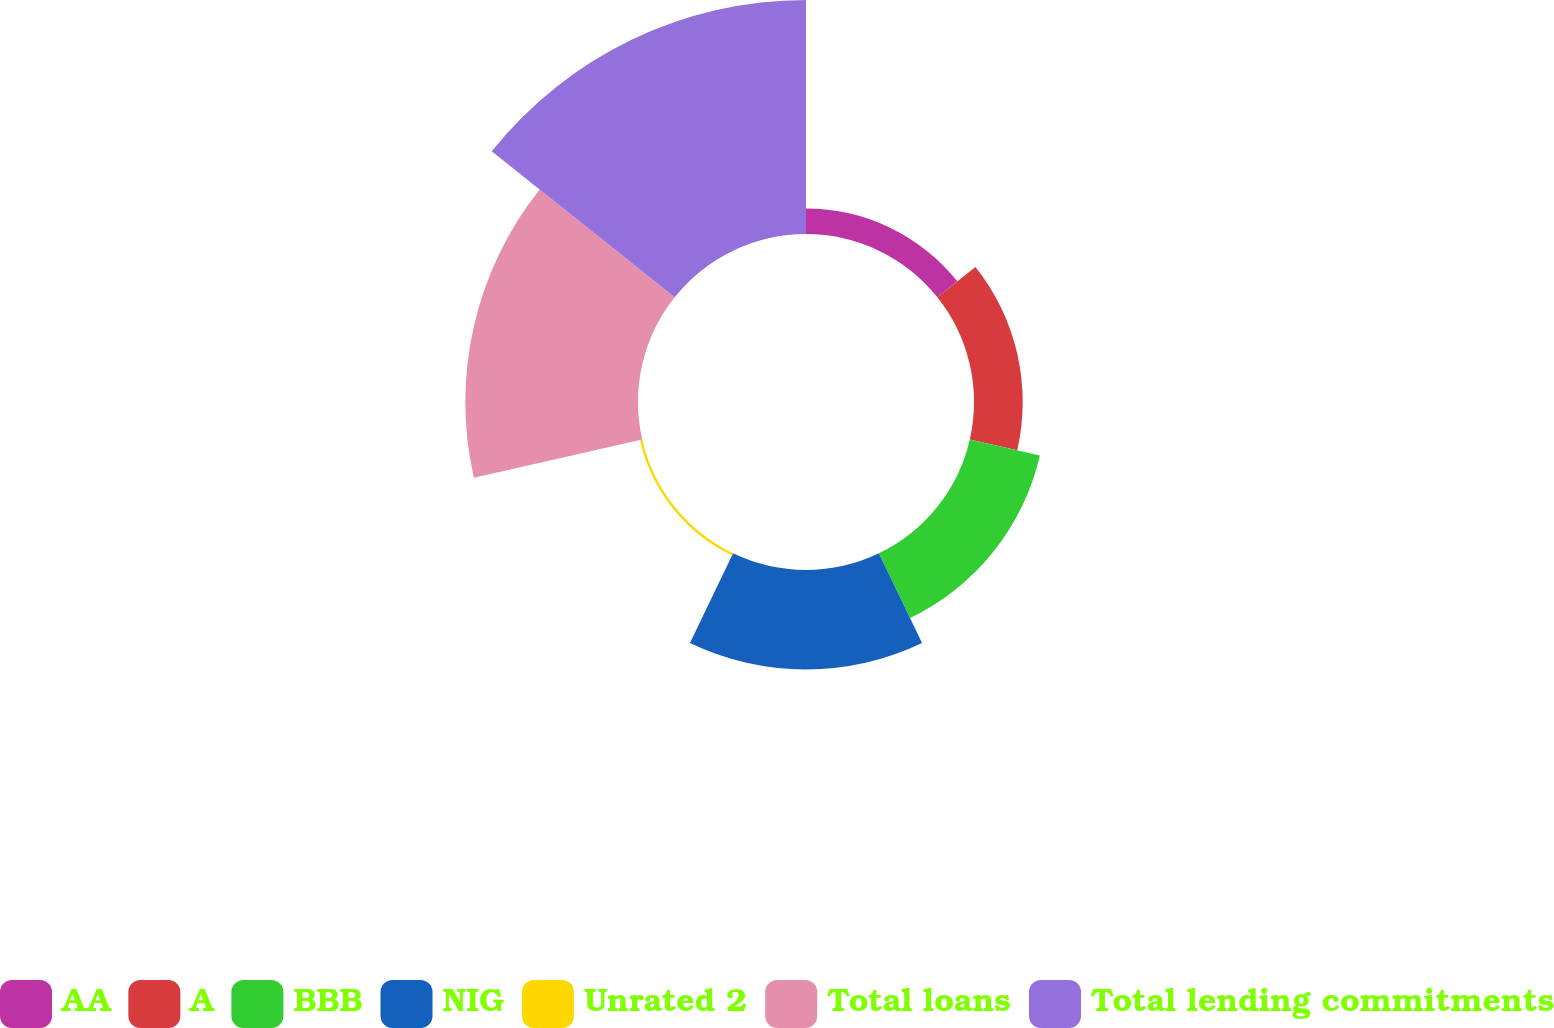Convert chart to OTSL. <chart><loc_0><loc_0><loc_500><loc_500><pie_chart><fcel>AA<fcel>A<fcel>BBB<fcel>NIG<fcel>Unrated 2<fcel>Total loans<fcel>Total lending commitments<nl><fcel>3.9%<fcel>7.44%<fcel>10.98%<fcel>15.19%<fcel>0.36%<fcel>26.38%<fcel>35.75%<nl></chart> 